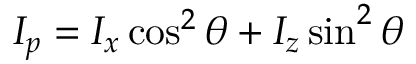<formula> <loc_0><loc_0><loc_500><loc_500>I _ { p } = I _ { x } \cos ^ { 2 } \theta + I _ { z } \sin ^ { 2 } \theta</formula> 